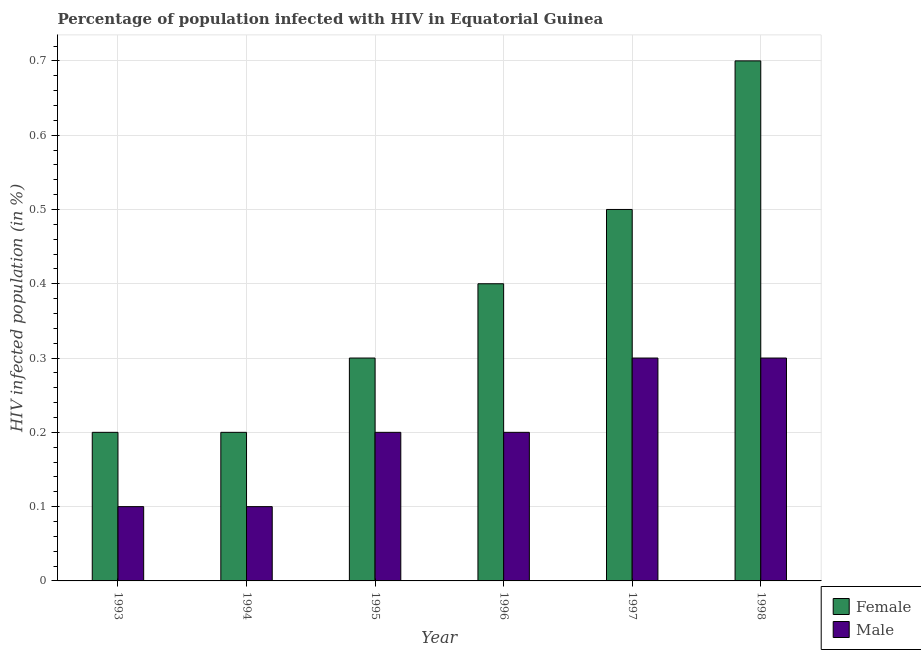Are the number of bars per tick equal to the number of legend labels?
Offer a terse response. Yes. Are the number of bars on each tick of the X-axis equal?
Offer a very short reply. Yes. How many bars are there on the 5th tick from the left?
Provide a short and direct response. 2. How many bars are there on the 2nd tick from the right?
Ensure brevity in your answer.  2. What is the percentage of males who are infected with hiv in 1998?
Give a very brief answer. 0.3. Across all years, what is the maximum percentage of females who are infected with hiv?
Give a very brief answer. 0.7. Across all years, what is the minimum percentage of males who are infected with hiv?
Offer a very short reply. 0.1. What is the total percentage of males who are infected with hiv in the graph?
Keep it short and to the point. 1.2. What is the difference between the percentage of males who are infected with hiv in 1994 and that in 1995?
Your response must be concise. -0.1. What is the difference between the percentage of males who are infected with hiv in 1996 and the percentage of females who are infected with hiv in 1994?
Your answer should be compact. 0.1. What is the average percentage of females who are infected with hiv per year?
Your answer should be very brief. 0.38. Is the percentage of females who are infected with hiv in 1997 less than that in 1998?
Your answer should be compact. Yes. What is the difference between the highest and the second highest percentage of females who are infected with hiv?
Your response must be concise. 0.2. What is the difference between the highest and the lowest percentage of females who are infected with hiv?
Offer a terse response. 0.5. In how many years, is the percentage of females who are infected with hiv greater than the average percentage of females who are infected with hiv taken over all years?
Ensure brevity in your answer.  3. Is the sum of the percentage of males who are infected with hiv in 1993 and 1995 greater than the maximum percentage of females who are infected with hiv across all years?
Your answer should be compact. Yes. How many bars are there?
Your answer should be compact. 12. Are all the bars in the graph horizontal?
Offer a terse response. No. What is the difference between two consecutive major ticks on the Y-axis?
Offer a very short reply. 0.1. What is the title of the graph?
Keep it short and to the point. Percentage of population infected with HIV in Equatorial Guinea. What is the label or title of the X-axis?
Make the answer very short. Year. What is the label or title of the Y-axis?
Provide a short and direct response. HIV infected population (in %). What is the HIV infected population (in %) of Female in 1994?
Your response must be concise. 0.2. What is the HIV infected population (in %) of Female in 1995?
Provide a succinct answer. 0.3. What is the HIV infected population (in %) in Male in 1995?
Give a very brief answer. 0.2. What is the HIV infected population (in %) in Female in 1996?
Your response must be concise. 0.4. What is the HIV infected population (in %) in Male in 1997?
Your response must be concise. 0.3. Across all years, what is the maximum HIV infected population (in %) of Female?
Make the answer very short. 0.7. Across all years, what is the maximum HIV infected population (in %) of Male?
Your response must be concise. 0.3. Across all years, what is the minimum HIV infected population (in %) in Male?
Provide a short and direct response. 0.1. What is the total HIV infected population (in %) of Female in the graph?
Give a very brief answer. 2.3. What is the difference between the HIV infected population (in %) of Male in 1993 and that in 1994?
Your answer should be very brief. 0. What is the difference between the HIV infected population (in %) in Male in 1993 and that in 1995?
Your response must be concise. -0.1. What is the difference between the HIV infected population (in %) in Female in 1993 and that in 1997?
Ensure brevity in your answer.  -0.3. What is the difference between the HIV infected population (in %) of Female in 1994 and that in 1995?
Your answer should be very brief. -0.1. What is the difference between the HIV infected population (in %) of Male in 1994 and that in 1995?
Provide a succinct answer. -0.1. What is the difference between the HIV infected population (in %) in Female in 1994 and that in 1997?
Your answer should be very brief. -0.3. What is the difference between the HIV infected population (in %) of Male in 1994 and that in 1997?
Give a very brief answer. -0.2. What is the difference between the HIV infected population (in %) in Female in 1994 and that in 1998?
Offer a very short reply. -0.5. What is the difference between the HIV infected population (in %) in Male in 1994 and that in 1998?
Offer a terse response. -0.2. What is the difference between the HIV infected population (in %) of Female in 1995 and that in 1997?
Keep it short and to the point. -0.2. What is the difference between the HIV infected population (in %) in Male in 1995 and that in 1998?
Give a very brief answer. -0.1. What is the difference between the HIV infected population (in %) of Female in 1996 and that in 1997?
Provide a short and direct response. -0.1. What is the difference between the HIV infected population (in %) of Male in 1996 and that in 1997?
Your answer should be compact. -0.1. What is the difference between the HIV infected population (in %) of Female in 1996 and that in 1998?
Your answer should be compact. -0.3. What is the difference between the HIV infected population (in %) of Male in 1997 and that in 1998?
Offer a very short reply. 0. What is the difference between the HIV infected population (in %) in Female in 1993 and the HIV infected population (in %) in Male in 1995?
Give a very brief answer. 0. What is the difference between the HIV infected population (in %) of Female in 1993 and the HIV infected population (in %) of Male in 1996?
Your answer should be compact. 0. What is the difference between the HIV infected population (in %) in Female in 1993 and the HIV infected population (in %) in Male in 1997?
Offer a very short reply. -0.1. What is the difference between the HIV infected population (in %) of Female in 1994 and the HIV infected population (in %) of Male in 1995?
Provide a short and direct response. 0. What is the difference between the HIV infected population (in %) of Female in 1995 and the HIV infected population (in %) of Male in 1997?
Give a very brief answer. 0. What is the difference between the HIV infected population (in %) in Female in 1995 and the HIV infected population (in %) in Male in 1998?
Ensure brevity in your answer.  0. What is the difference between the HIV infected population (in %) in Female in 1996 and the HIV infected population (in %) in Male in 1998?
Provide a short and direct response. 0.1. What is the difference between the HIV infected population (in %) in Female in 1997 and the HIV infected population (in %) in Male in 1998?
Your answer should be compact. 0.2. What is the average HIV infected population (in %) of Female per year?
Offer a terse response. 0.38. In the year 1993, what is the difference between the HIV infected population (in %) in Female and HIV infected population (in %) in Male?
Provide a succinct answer. 0.1. In the year 1994, what is the difference between the HIV infected population (in %) in Female and HIV infected population (in %) in Male?
Offer a very short reply. 0.1. In the year 1995, what is the difference between the HIV infected population (in %) of Female and HIV infected population (in %) of Male?
Your answer should be very brief. 0.1. In the year 1996, what is the difference between the HIV infected population (in %) in Female and HIV infected population (in %) in Male?
Your response must be concise. 0.2. What is the ratio of the HIV infected population (in %) of Female in 1993 to that in 1994?
Provide a succinct answer. 1. What is the ratio of the HIV infected population (in %) in Male in 1993 to that in 1994?
Offer a terse response. 1. What is the ratio of the HIV infected population (in %) of Male in 1993 to that in 1995?
Your response must be concise. 0.5. What is the ratio of the HIV infected population (in %) in Male in 1993 to that in 1996?
Your response must be concise. 0.5. What is the ratio of the HIV infected population (in %) in Male in 1993 to that in 1997?
Offer a very short reply. 0.33. What is the ratio of the HIV infected population (in %) of Female in 1993 to that in 1998?
Your answer should be compact. 0.29. What is the ratio of the HIV infected population (in %) in Male in 1993 to that in 1998?
Keep it short and to the point. 0.33. What is the ratio of the HIV infected population (in %) of Female in 1994 to that in 1995?
Provide a succinct answer. 0.67. What is the ratio of the HIV infected population (in %) in Female in 1994 to that in 1996?
Keep it short and to the point. 0.5. What is the ratio of the HIV infected population (in %) in Male in 1994 to that in 1996?
Ensure brevity in your answer.  0.5. What is the ratio of the HIV infected population (in %) in Female in 1994 to that in 1997?
Make the answer very short. 0.4. What is the ratio of the HIV infected population (in %) of Male in 1994 to that in 1997?
Give a very brief answer. 0.33. What is the ratio of the HIV infected population (in %) in Female in 1994 to that in 1998?
Your answer should be compact. 0.29. What is the ratio of the HIV infected population (in %) in Male in 1994 to that in 1998?
Your response must be concise. 0.33. What is the ratio of the HIV infected population (in %) of Male in 1995 to that in 1997?
Give a very brief answer. 0.67. What is the ratio of the HIV infected population (in %) in Female in 1995 to that in 1998?
Provide a short and direct response. 0.43. What is the ratio of the HIV infected population (in %) in Male in 1996 to that in 1998?
Ensure brevity in your answer.  0.67. What is the difference between the highest and the second highest HIV infected population (in %) in Female?
Offer a very short reply. 0.2. What is the difference between the highest and the second highest HIV infected population (in %) in Male?
Provide a succinct answer. 0. What is the difference between the highest and the lowest HIV infected population (in %) in Female?
Provide a short and direct response. 0.5. 